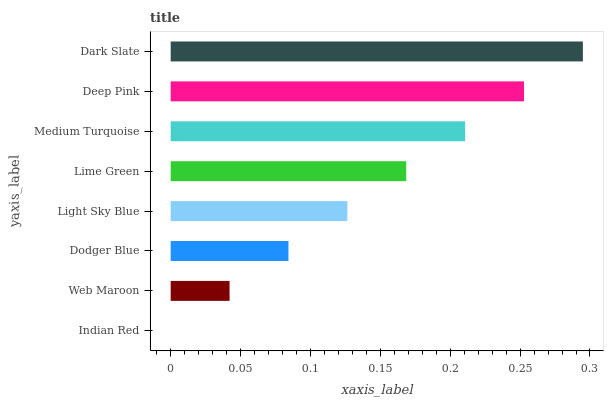Is Indian Red the minimum?
Answer yes or no. Yes. Is Dark Slate the maximum?
Answer yes or no. Yes. Is Web Maroon the minimum?
Answer yes or no. No. Is Web Maroon the maximum?
Answer yes or no. No. Is Web Maroon greater than Indian Red?
Answer yes or no. Yes. Is Indian Red less than Web Maroon?
Answer yes or no. Yes. Is Indian Red greater than Web Maroon?
Answer yes or no. No. Is Web Maroon less than Indian Red?
Answer yes or no. No. Is Lime Green the high median?
Answer yes or no. Yes. Is Light Sky Blue the low median?
Answer yes or no. Yes. Is Indian Red the high median?
Answer yes or no. No. Is Dark Slate the low median?
Answer yes or no. No. 